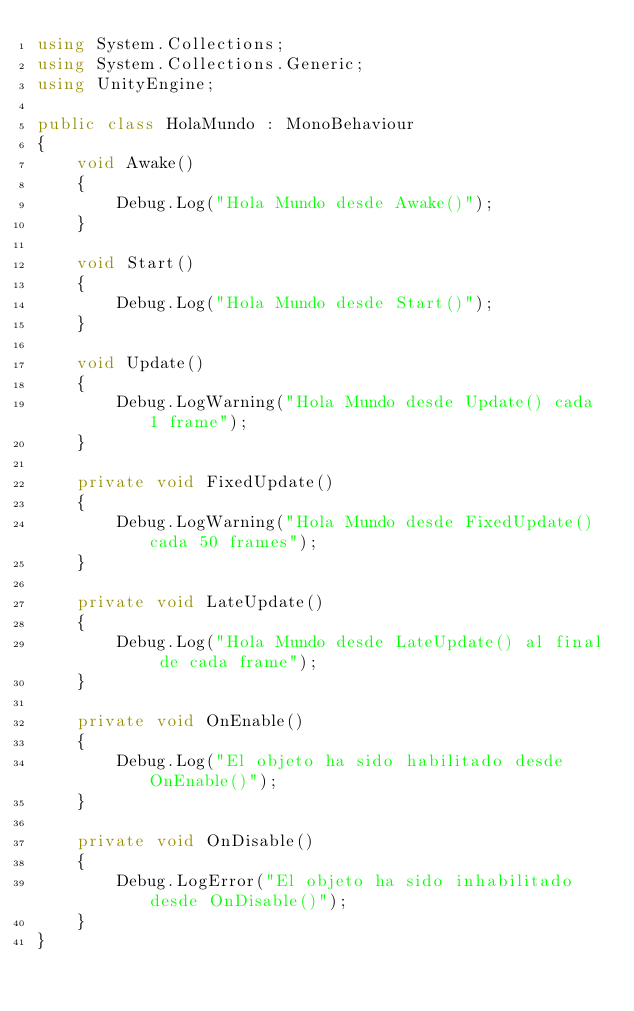<code> <loc_0><loc_0><loc_500><loc_500><_C#_>using System.Collections;
using System.Collections.Generic;
using UnityEngine;

public class HolaMundo : MonoBehaviour
{
    void Awake()
    {
        Debug.Log("Hola Mundo desde Awake()");
    }

    void Start()
    {
        Debug.Log("Hola Mundo desde Start()");
    }

    void Update()
    {
        Debug.LogWarning("Hola Mundo desde Update() cada 1 frame");
    }

    private void FixedUpdate()
    {
        Debug.LogWarning("Hola Mundo desde FixedUpdate() cada 50 frames");
    }

    private void LateUpdate()
    {
        Debug.Log("Hola Mundo desde LateUpdate() al final de cada frame");
    }

    private void OnEnable()
    {
        Debug.Log("El objeto ha sido habilitado desde OnEnable()");
    }

    private void OnDisable()
    {
        Debug.LogError("El objeto ha sido inhabilitado desde OnDisable()");
    }
}
</code> 